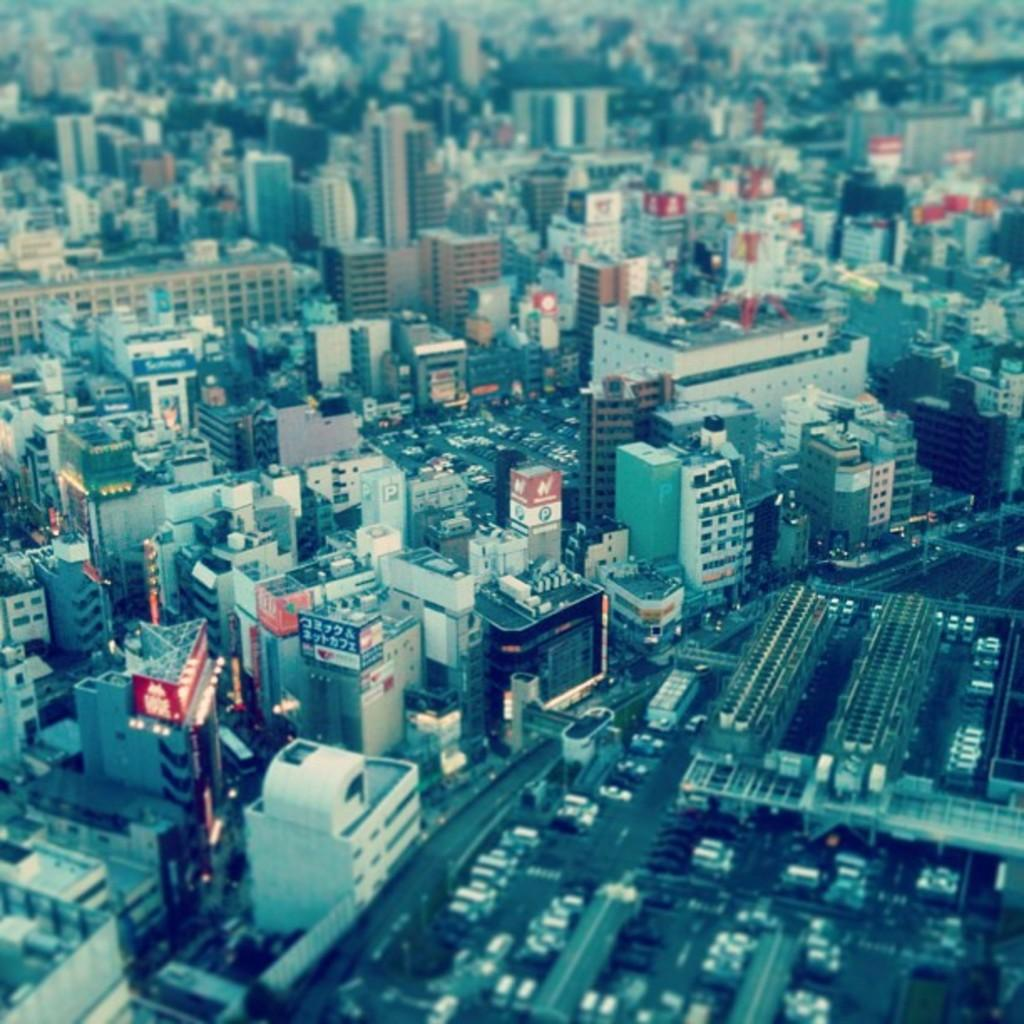What type of view is shown in the image? The image is a top view of a city. What can be seen in the image from this perspective? There are many buildings visible in the image. What type of shame can be seen on the faces of the children in the image? There are no children present in the image, so it is not possible to determine if they are experiencing any shame. 